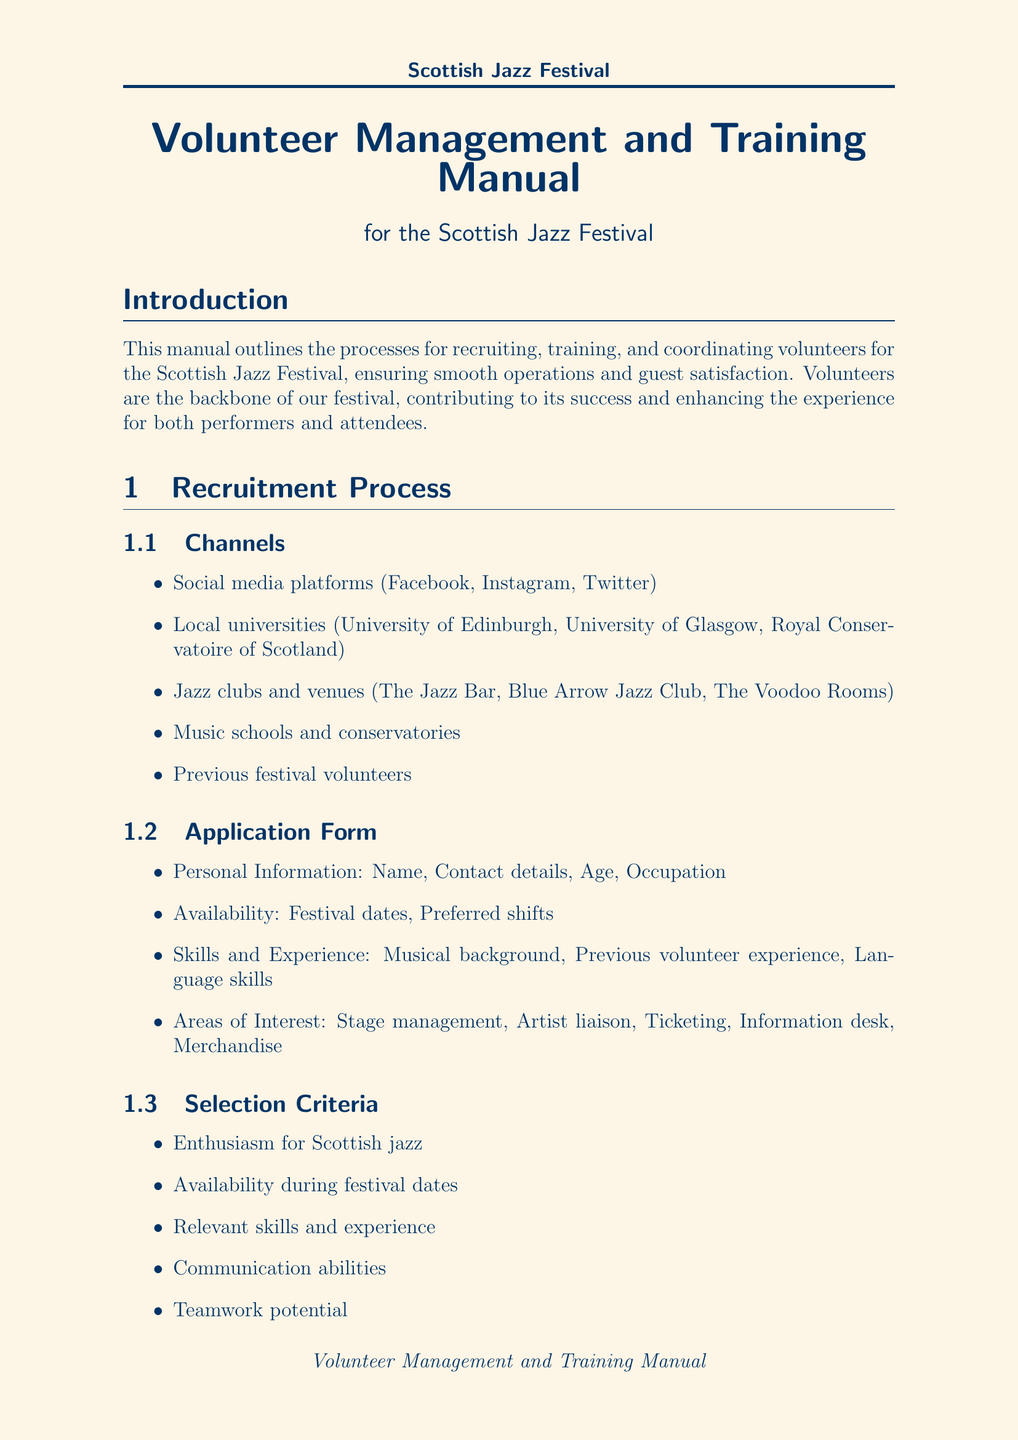What is the purpose of the manual? The purpose of the manual is outlined in the introduction section as the processes for recruiting, training, and coordinating volunteers for the Scottish Jazz Festival, ensuring smooth operations and guest satisfaction.
Answer: Recruiting, training, and coordinating volunteers What are the main stages for the festival? The festival includes various venues, which are listed in the venue information section under "main stage," "jazz club stage," and "outdoor performance area."
Answer: Edinburgh Corn Exchange, The Jazz Bar, Princes Street Gardens What is the duration of the orientation session? The document specifies that the orientation session is a part of the training program and its duration is mentioned directly.
Answer: 4 hours What are two channels used for volunteer recruitment? The recruitment process mentions several channels, including social media and local universities, for volunteer recruitment.
Answer: Social media platforms, Local universities What are the key performance indicators listed in the document? The performance evaluation section includes key performance indicators that measure aspects such as punctuality and reliability, task completion and efficiency, and others.
Answer: Punctuality and reliability, Task completion and efficiency How many responsibilities does the volunteer coordinator have? The responsibilities of the volunteer coordinator are listed in a bullet point format; counting these will yield the number of responsibilities.
Answer: Five What is one method mentioned for providing feedback to volunteers? The document lists several methods under the feedback section, with post-shift debriefs being one of them.
Answer: Post-shift debriefs What is offered as a form of recognition for volunteers? The recognition and appreciation section mentions multiple forms of appreciation, including a volunteer appreciation party.
Answer: Volunteer appreciation party with live jazz performance 